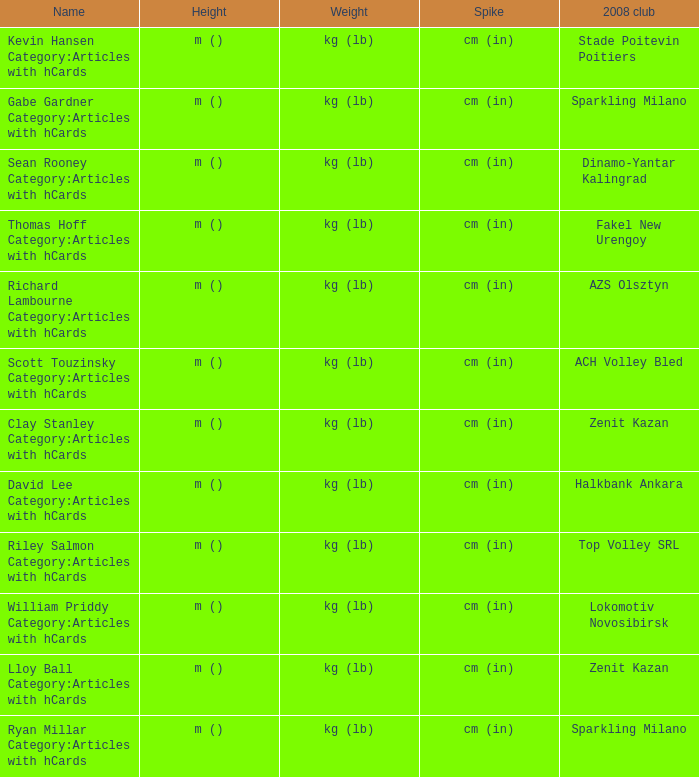What is the spike for the 2008 club of Lokomotiv Novosibirsk? Cm (in). 